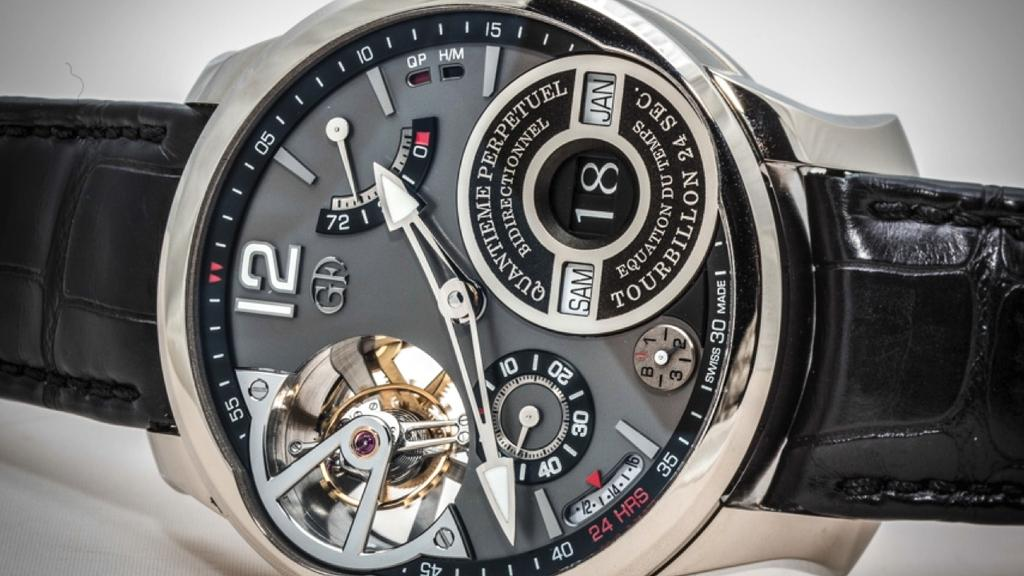<image>
Present a compact description of the photo's key features. a watch labeled Quantieme Perpetuel with an interesting open design 